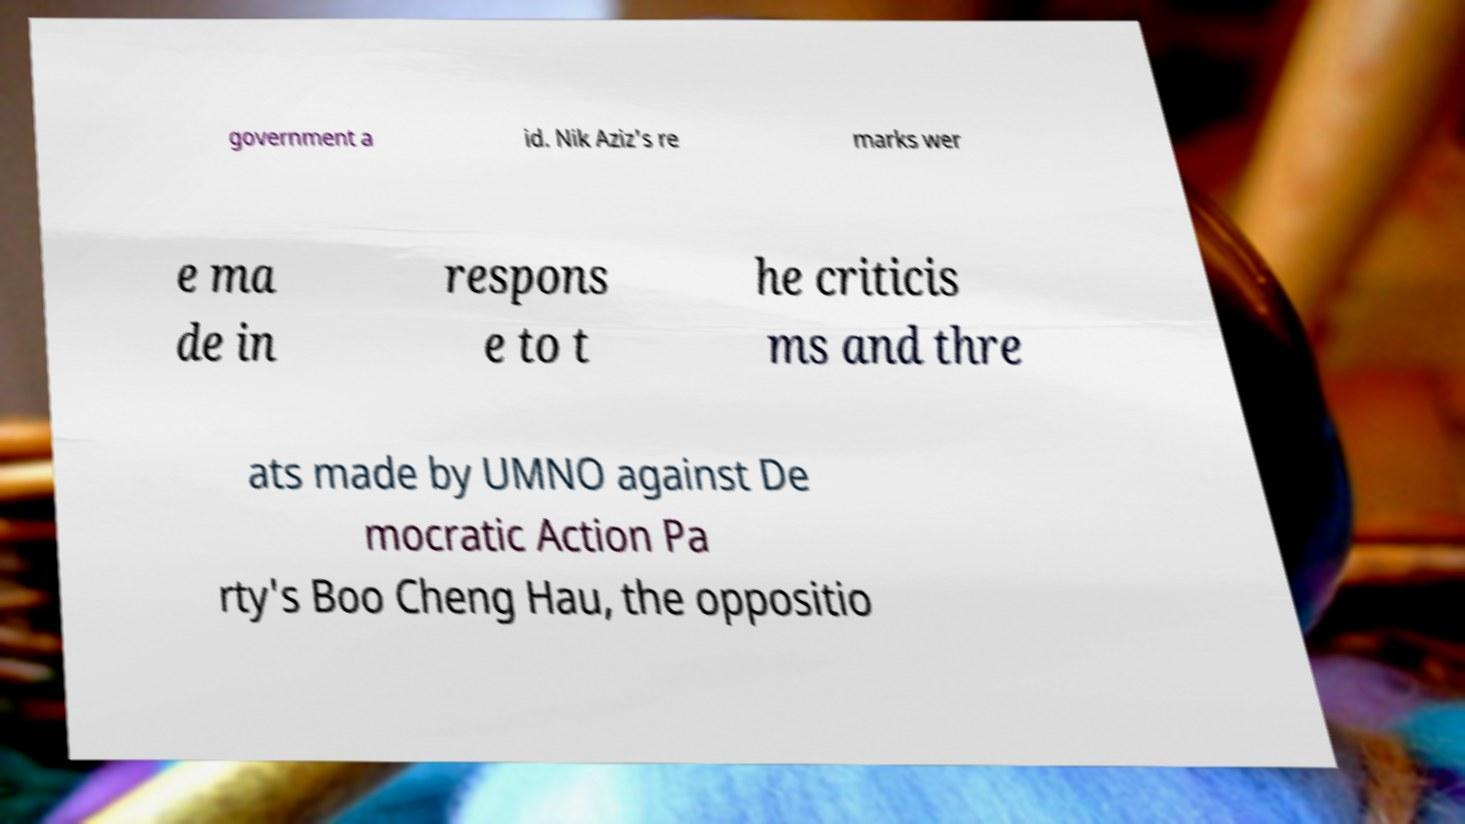Could you extract and type out the text from this image? government a id. Nik Aziz's re marks wer e ma de in respons e to t he criticis ms and thre ats made by UMNO against De mocratic Action Pa rty's Boo Cheng Hau, the oppositio 